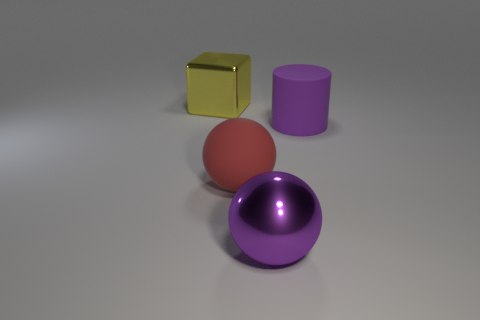Are there any big brown cubes that have the same material as the purple sphere?
Offer a very short reply. No. What size is the sphere that is the same color as the cylinder?
Provide a succinct answer. Large. The big sphere behind the big metallic thing that is right of the yellow metallic object is what color?
Offer a very short reply. Red. Does the cylinder have the same size as the red object?
Give a very brief answer. Yes. How many blocks are purple rubber objects or big red matte objects?
Ensure brevity in your answer.  0. There is a large purple matte object on the right side of the big purple shiny thing; how many shiny spheres are left of it?
Provide a succinct answer. 1. Is the shape of the yellow object the same as the red matte thing?
Give a very brief answer. No. What size is the other thing that is the same shape as the red rubber thing?
Give a very brief answer. Large. There is a big purple thing on the left side of the matte thing right of the metallic ball; what shape is it?
Provide a succinct answer. Sphere. What is the size of the metal block?
Provide a short and direct response. Large. 